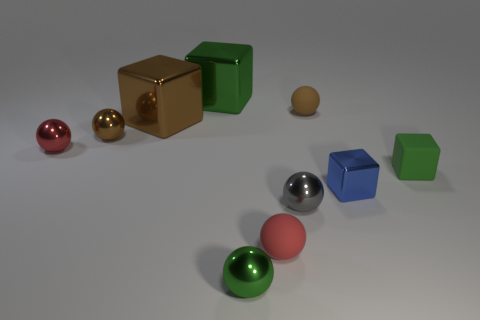Do the tiny matte object that is behind the matte block and the tiny red matte object have the same shape?
Your response must be concise. Yes. What number of brown objects are either tiny metal objects or shiny balls?
Your response must be concise. 1. Are there an equal number of small spheres that are behind the brown rubber object and balls in front of the large brown thing?
Your response must be concise. No. What color is the small rubber thing behind the tiny green thing behind the rubber thing that is in front of the tiny blue block?
Give a very brief answer. Brown. Is there anything else that has the same color as the tiny metal cube?
Offer a very short reply. No. The large metal thing that is the same color as the tiny rubber cube is what shape?
Your response must be concise. Cube. There is a red ball right of the small brown shiny thing; what size is it?
Provide a succinct answer. Small. There is a brown shiny object that is the same size as the gray thing; what is its shape?
Give a very brief answer. Sphere. Do the red sphere in front of the tiny red metal sphere and the small red object behind the gray object have the same material?
Ensure brevity in your answer.  No. What is the red ball that is to the left of the red ball that is in front of the red shiny object made of?
Make the answer very short. Metal. 